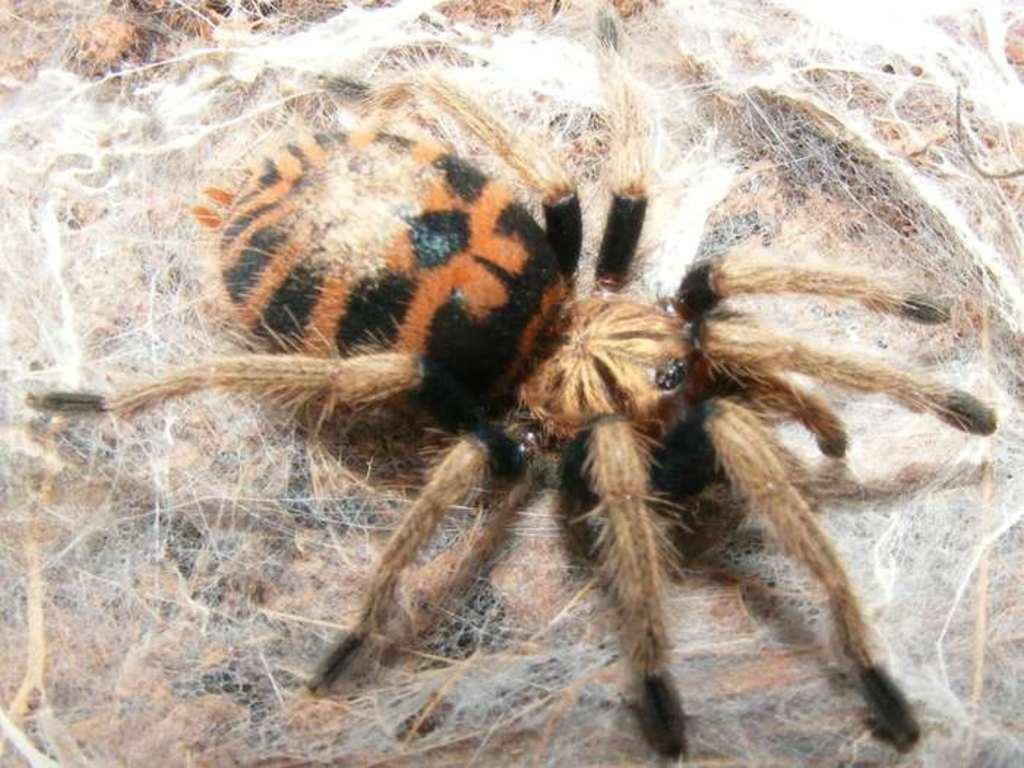What type of animals are present in the image? There are two spiders in the image, one brown and one black. Where are the spiders located in the image? Both spiders are on a web. How much water is present in the lake shown in the image? There is no lake present in the image; it features two spiders on a web. What type of boundary can be seen between the two spiders in the image? There is no boundary between the two spiders in the image; they are both on the same web. 